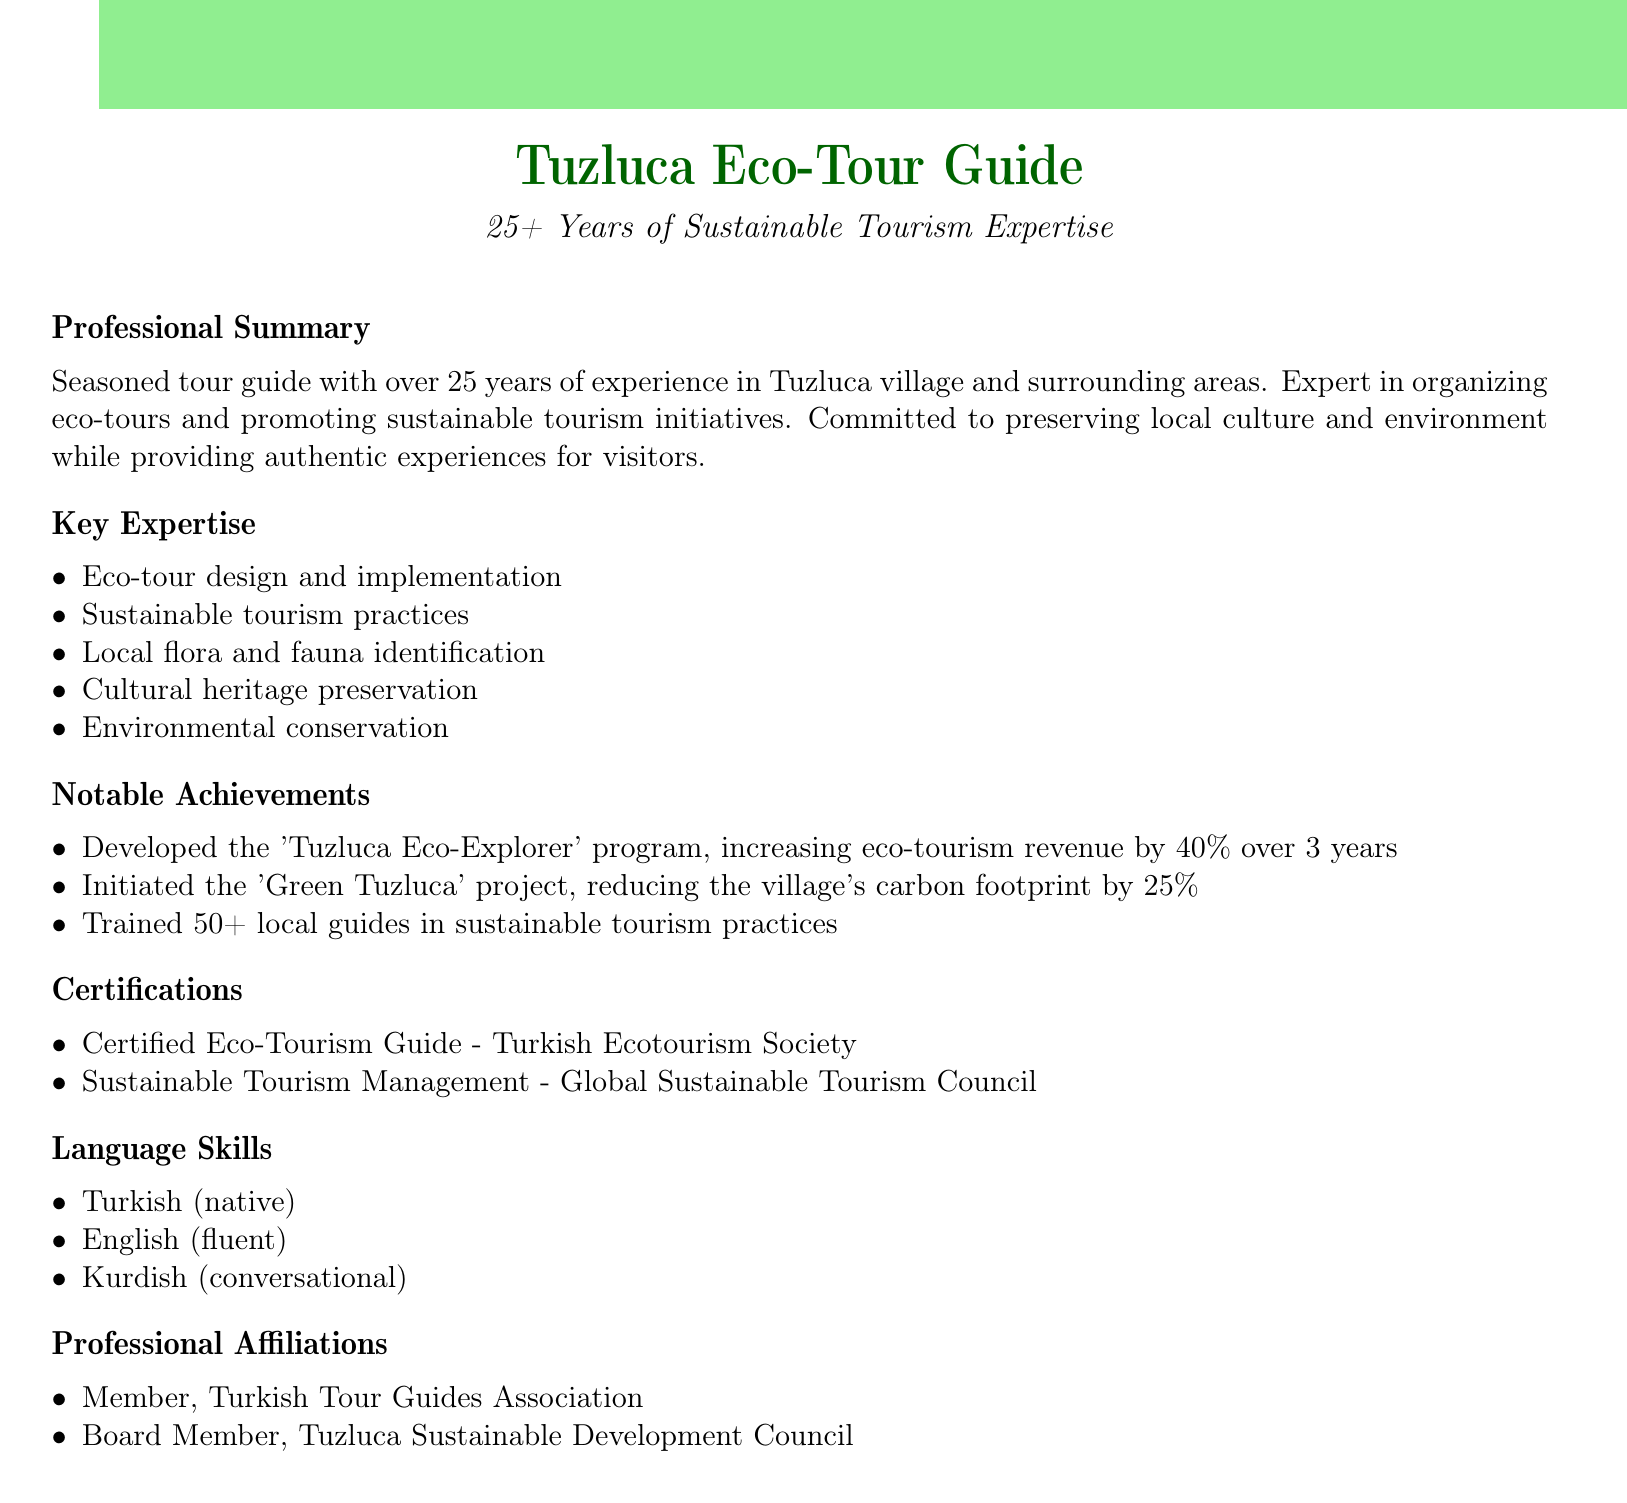What is the professional summary? The professional summary outlines the tour guide's experience and expertise in organizing eco-tours and sustainable tourism initiatives in Tuzluca.
Answer: Seasoned tour guide with over 25 years of experience in Tuzluca village and surrounding areas. Expert in organizing eco-tours and promoting sustainable tourism initiatives. Committed to preserving local culture and environment while providing authentic experiences for visitors How many years of experience does the tour guide have? The document states the total years of experience of the tour guide mentioned in the professional summary.
Answer: 25 years What percentage did the 'Tuzluca Eco-Explorer' program increase eco-tourism revenue? The notable achievement specifies the percentage increase in eco-tourism revenue over three years.
Answer: 40% Which organization certified the Eco-Tourism Guide? The document lists the certification related to eco-tourism along with the issuing organization.
Answer: Turkish Ecotourism Society How many local guides were trained in sustainable tourism practices? The notable achievements section details the number of local guides trained in sustainable tourism practices.
Answer: 50+ What is the language proficiency level in English? The language skills section indicates the fluency level in English as described in the document.
Answer: Fluent Which council is mentioned as part of professional affiliations? The document highlights a specific council that the tour guide is affiliated with.
Answer: Tuzluca Sustainable Development Council What is the main focus of the 'Green Tuzluca' project? The notable achievement describes the objective of the 'Green Tuzluca' project.
Answer: Reducing carbon footprint What type of tourism practices does the professional summary emphasize? The professional summary highlights the tour guide's expertise type related to tourism practices.
Answer: Sustainable tourism 